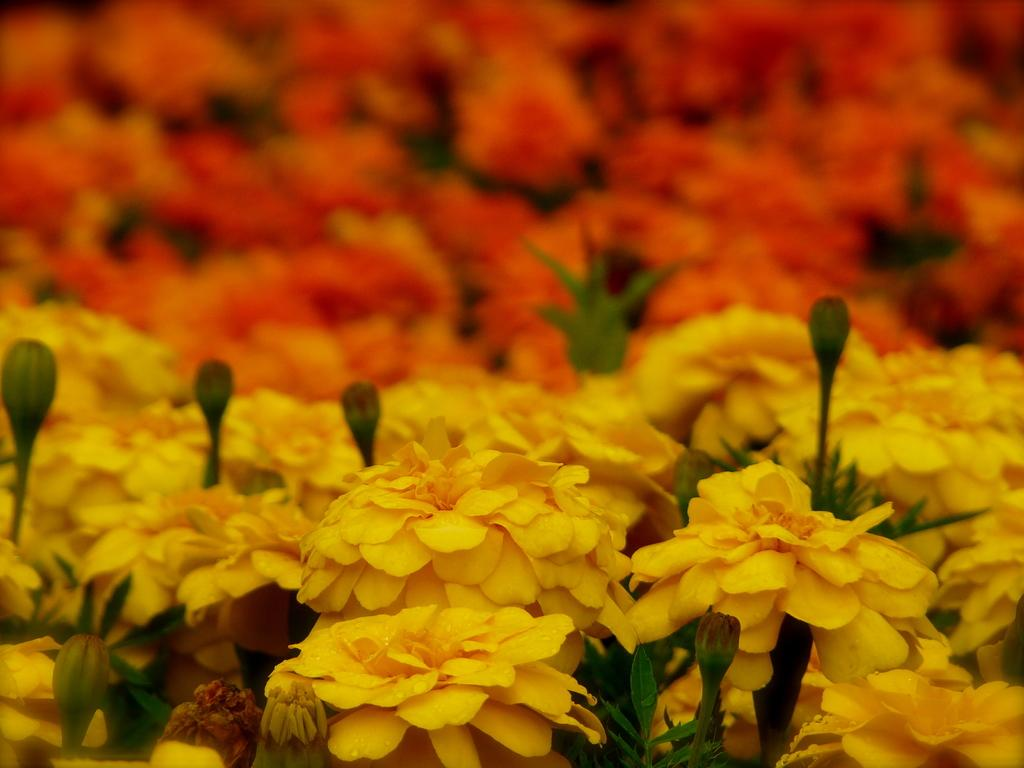What can be seen in the foreground of the picture? There are flowers, buds, and leaves in the foreground of the picture. Can you describe the flowers in the foreground? The flowers in the foreground are accompanied by buds and leaves. What is the condition of the top part of the image? The top part of the image is blurred. How many bridges can be seen in the yard in the image? There is no yard or bridge present in the image; it features flowers, buds, and leaves in the foreground with a blurred top part. 